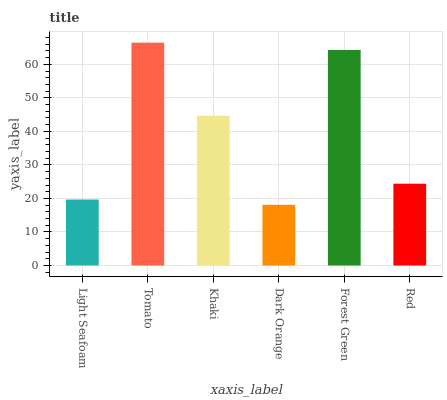Is Dark Orange the minimum?
Answer yes or no. Yes. Is Tomato the maximum?
Answer yes or no. Yes. Is Khaki the minimum?
Answer yes or no. No. Is Khaki the maximum?
Answer yes or no. No. Is Tomato greater than Khaki?
Answer yes or no. Yes. Is Khaki less than Tomato?
Answer yes or no. Yes. Is Khaki greater than Tomato?
Answer yes or no. No. Is Tomato less than Khaki?
Answer yes or no. No. Is Khaki the high median?
Answer yes or no. Yes. Is Red the low median?
Answer yes or no. Yes. Is Forest Green the high median?
Answer yes or no. No. Is Dark Orange the low median?
Answer yes or no. No. 